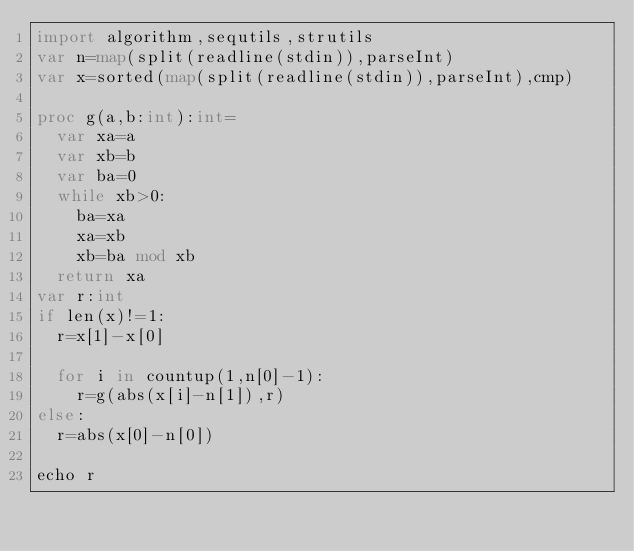<code> <loc_0><loc_0><loc_500><loc_500><_Nim_>import algorithm,sequtils,strutils
var n=map(split(readline(stdin)),parseInt)
var x=sorted(map(split(readline(stdin)),parseInt),cmp)

proc g(a,b:int):int=
  var xa=a
  var xb=b
  var ba=0
  while xb>0:
    ba=xa
    xa=xb
    xb=ba mod xb
  return xa
var r:int
if len(x)!=1:
  r=x[1]-x[0]

  for i in countup(1,n[0]-1):
    r=g(abs(x[i]-n[1]),r)
else:
  r=abs(x[0]-n[0])

echo r</code> 